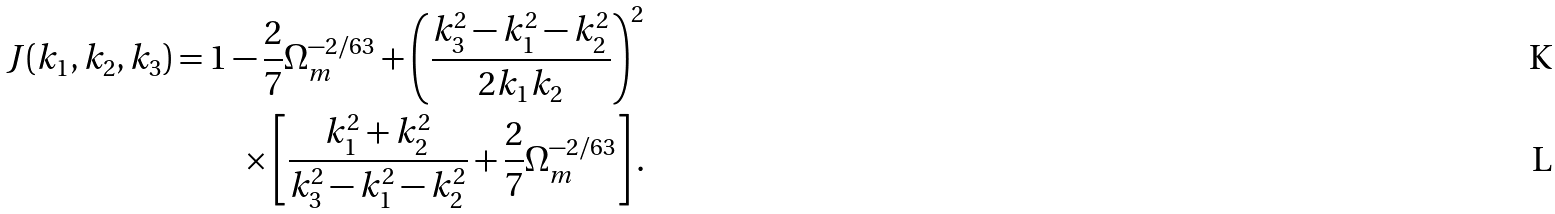Convert formula to latex. <formula><loc_0><loc_0><loc_500><loc_500>J ( k _ { 1 } , k _ { 2 } , k _ { 3 } ) = 1 - \frac { 2 } { 7 } \Omega _ { m } ^ { - 2 / 6 3 } + \left ( \frac { k _ { 3 } ^ { 2 } - k _ { 1 } ^ { 2 } - k _ { 2 } ^ { 2 } } { 2 k _ { 1 } k _ { 2 } } \right ) ^ { 2 } \\ \times \left [ \frac { k _ { 1 } ^ { 2 } + k _ { 2 } ^ { 2 } } { k _ { 3 } ^ { 2 } - k _ { 1 } ^ { 2 } - k _ { 2 } ^ { 2 } } + \frac { 2 } { 7 } \Omega _ { m } ^ { - 2 / 6 3 } \right ] .</formula> 